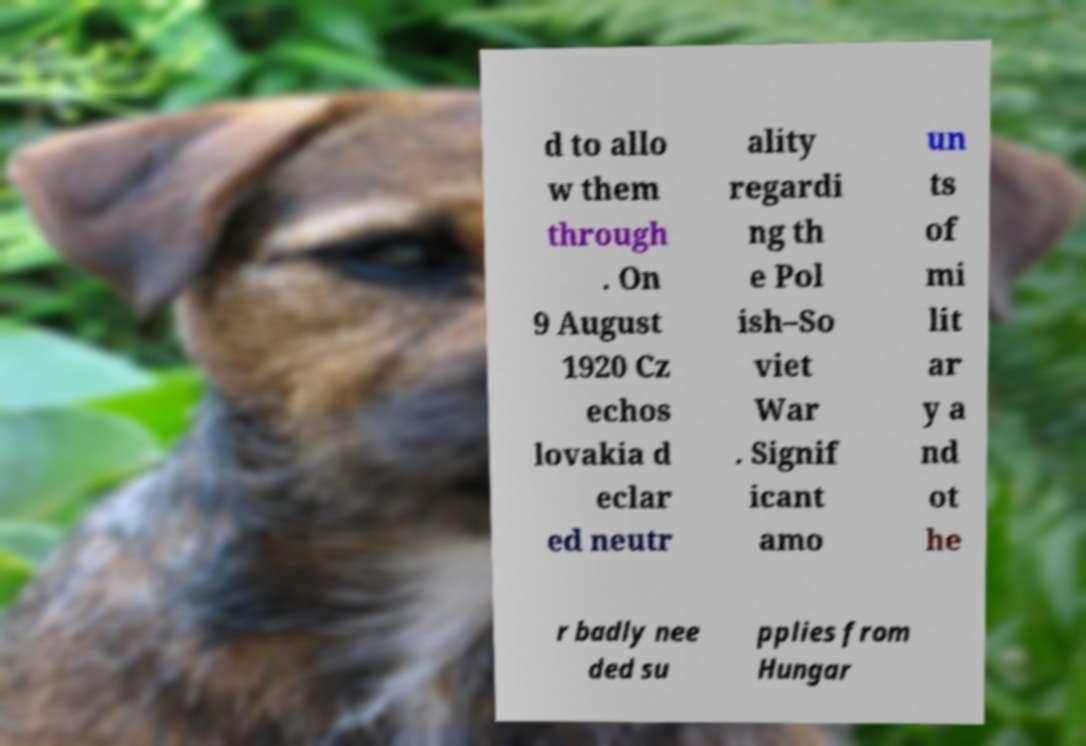There's text embedded in this image that I need extracted. Can you transcribe it verbatim? d to allo w them through . On 9 August 1920 Cz echos lovakia d eclar ed neutr ality regardi ng th e Pol ish–So viet War . Signif icant amo un ts of mi lit ar y a nd ot he r badly nee ded su pplies from Hungar 